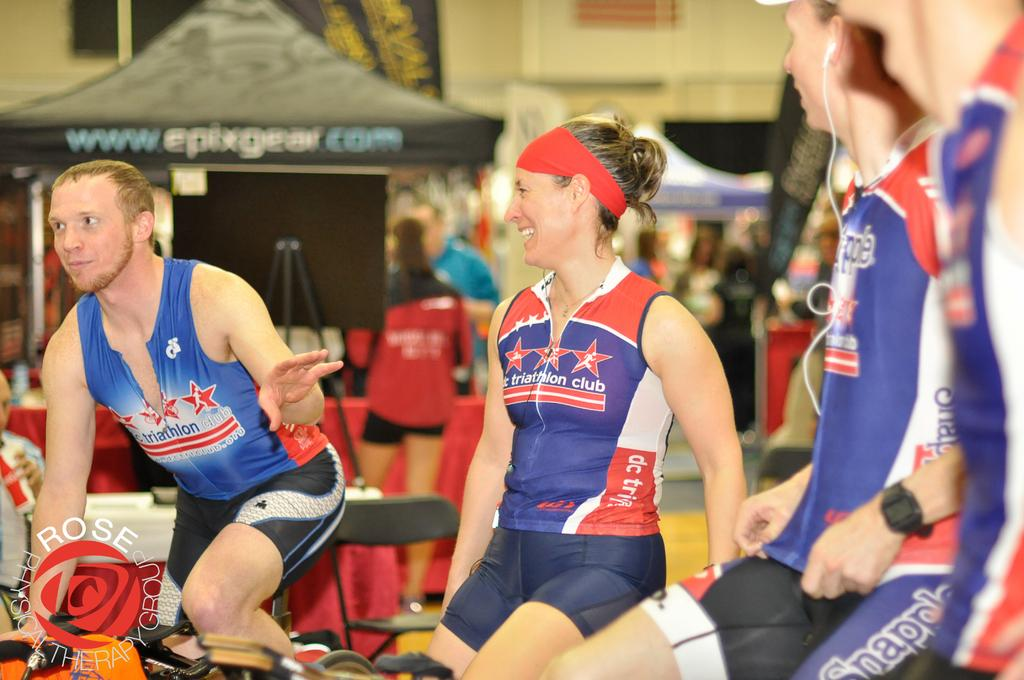<image>
Give a short and clear explanation of the subsequent image. A group of cyclists on bikes looking at a man pointing as they all wear epixgear cycling uniforms in red, white and blue colors 